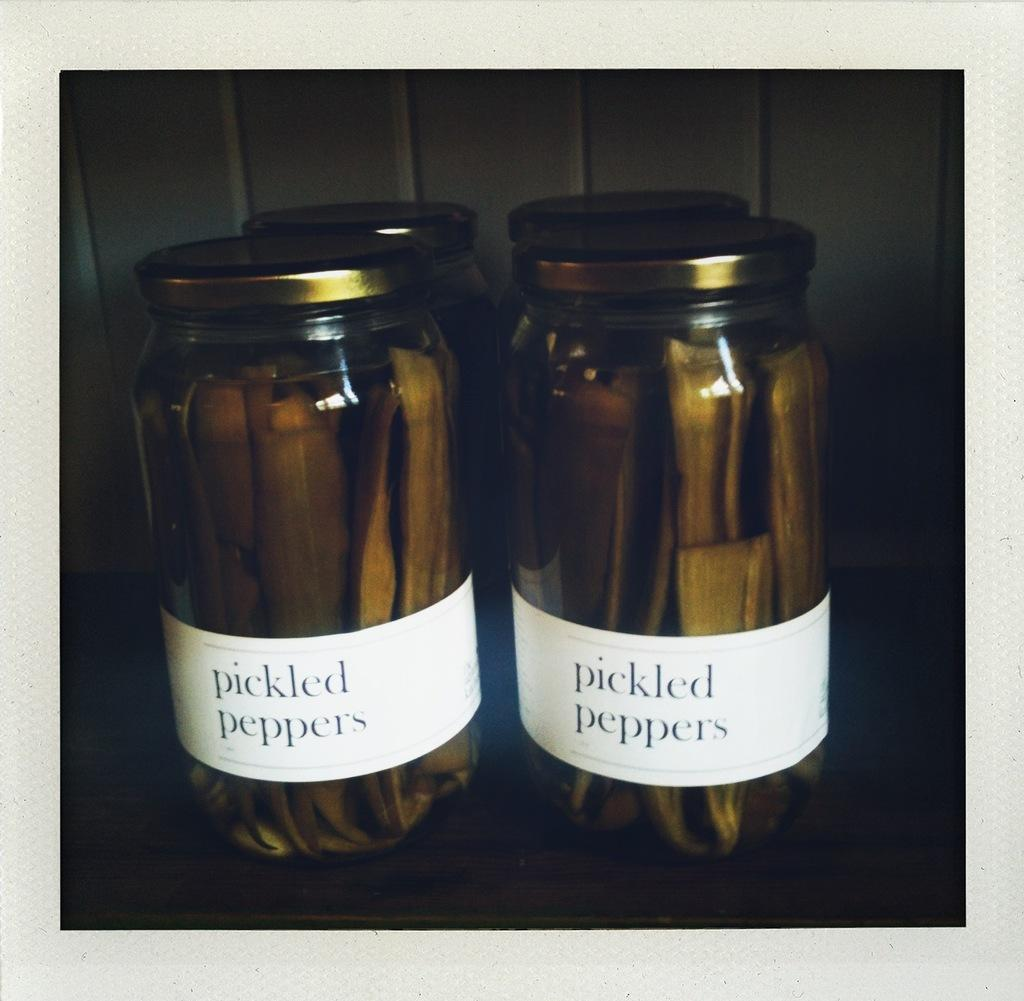<image>
Summarize the visual content of the image. the words pickled peppers that are on a jar 